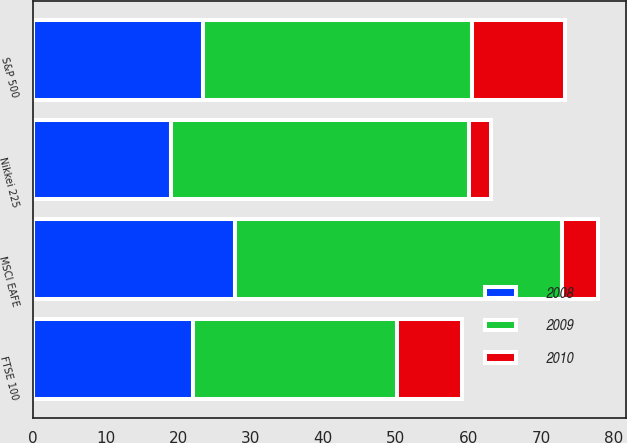Convert chart to OTSL. <chart><loc_0><loc_0><loc_500><loc_500><stacked_bar_chart><ecel><fcel>S&P 500<fcel>FTSE 100<fcel>Nikkei 225<fcel>MSCI EAFE<nl><fcel>2010<fcel>12.8<fcel>9<fcel>3<fcel>4.9<nl><fcel>2008<fcel>23.5<fcel>22.1<fcel>19<fcel>27.8<nl><fcel>2009<fcel>37<fcel>28<fcel>41.1<fcel>45.1<nl></chart> 